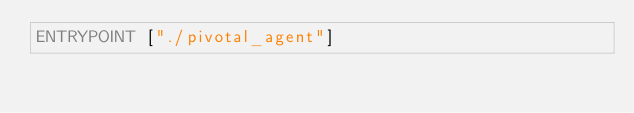<code> <loc_0><loc_0><loc_500><loc_500><_Dockerfile_>ENTRYPOINT ["./pivotal_agent"]

</code> 